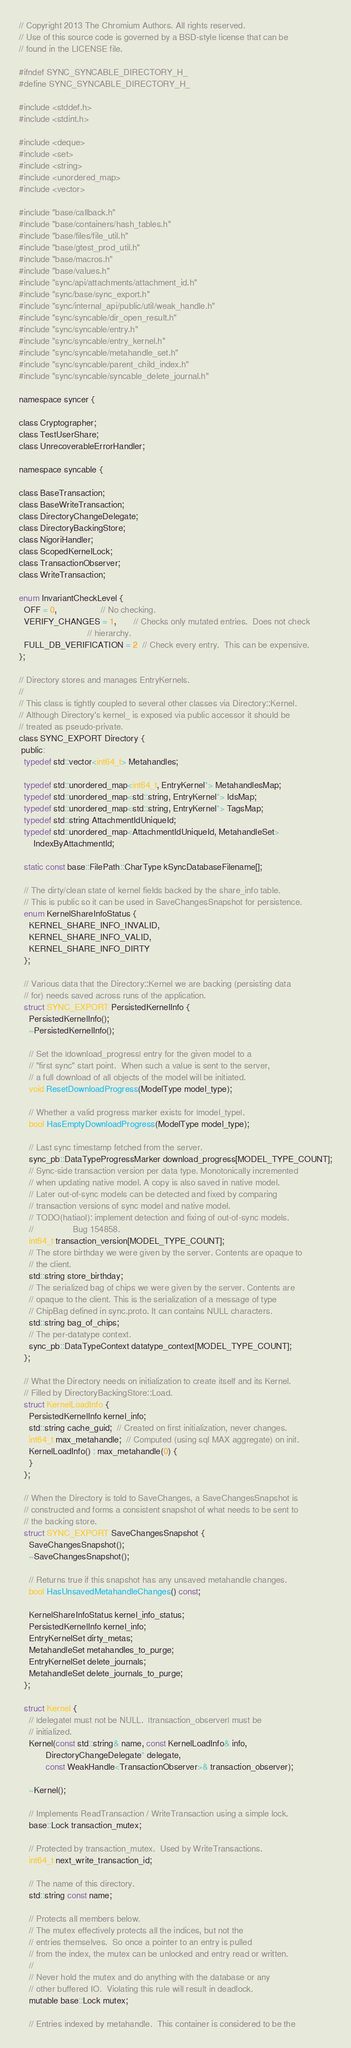<code> <loc_0><loc_0><loc_500><loc_500><_C_>// Copyright 2013 The Chromium Authors. All rights reserved.
// Use of this source code is governed by a BSD-style license that can be
// found in the LICENSE file.

#ifndef SYNC_SYNCABLE_DIRECTORY_H_
#define SYNC_SYNCABLE_DIRECTORY_H_

#include <stddef.h>
#include <stdint.h>

#include <deque>
#include <set>
#include <string>
#include <unordered_map>
#include <vector>

#include "base/callback.h"
#include "base/containers/hash_tables.h"
#include "base/files/file_util.h"
#include "base/gtest_prod_util.h"
#include "base/macros.h"
#include "base/values.h"
#include "sync/api/attachments/attachment_id.h"
#include "sync/base/sync_export.h"
#include "sync/internal_api/public/util/weak_handle.h"
#include "sync/syncable/dir_open_result.h"
#include "sync/syncable/entry.h"
#include "sync/syncable/entry_kernel.h"
#include "sync/syncable/metahandle_set.h"
#include "sync/syncable/parent_child_index.h"
#include "sync/syncable/syncable_delete_journal.h"

namespace syncer {

class Cryptographer;
class TestUserShare;
class UnrecoverableErrorHandler;

namespace syncable {

class BaseTransaction;
class BaseWriteTransaction;
class DirectoryChangeDelegate;
class DirectoryBackingStore;
class NigoriHandler;
class ScopedKernelLock;
class TransactionObserver;
class WriteTransaction;

enum InvariantCheckLevel {
  OFF = 0,                  // No checking.
  VERIFY_CHANGES = 1,       // Checks only mutated entries.  Does not check
                            // hierarchy.
  FULL_DB_VERIFICATION = 2  // Check every entry.  This can be expensive.
};

// Directory stores and manages EntryKernels.
//
// This class is tightly coupled to several other classes via Directory::Kernel.
// Although Directory's kernel_ is exposed via public accessor it should be
// treated as pseudo-private.
class SYNC_EXPORT Directory {
 public:
  typedef std::vector<int64_t> Metahandles;

  typedef std::unordered_map<int64_t, EntryKernel*> MetahandlesMap;
  typedef std::unordered_map<std::string, EntryKernel*> IdsMap;
  typedef std::unordered_map<std::string, EntryKernel*> TagsMap;
  typedef std::string AttachmentIdUniqueId;
  typedef std::unordered_map<AttachmentIdUniqueId, MetahandleSet>
      IndexByAttachmentId;

  static const base::FilePath::CharType kSyncDatabaseFilename[];

  // The dirty/clean state of kernel fields backed by the share_info table.
  // This is public so it can be used in SaveChangesSnapshot for persistence.
  enum KernelShareInfoStatus {
    KERNEL_SHARE_INFO_INVALID,
    KERNEL_SHARE_INFO_VALID,
    KERNEL_SHARE_INFO_DIRTY
  };

  // Various data that the Directory::Kernel we are backing (persisting data
  // for) needs saved across runs of the application.
  struct SYNC_EXPORT PersistedKernelInfo {
    PersistedKernelInfo();
    ~PersistedKernelInfo();

    // Set the |download_progress| entry for the given model to a
    // "first sync" start point.  When such a value is sent to the server,
    // a full download of all objects of the model will be initiated.
    void ResetDownloadProgress(ModelType model_type);

    // Whether a valid progress marker exists for |model_type|.
    bool HasEmptyDownloadProgress(ModelType model_type);

    // Last sync timestamp fetched from the server.
    sync_pb::DataTypeProgressMarker download_progress[MODEL_TYPE_COUNT];
    // Sync-side transaction version per data type. Monotonically incremented
    // when updating native model. A copy is also saved in native model.
    // Later out-of-sync models can be detected and fixed by comparing
    // transaction versions of sync model and native model.
    // TODO(hatiaol): implement detection and fixing of out-of-sync models.
    //                Bug 154858.
    int64_t transaction_version[MODEL_TYPE_COUNT];
    // The store birthday we were given by the server. Contents are opaque to
    // the client.
    std::string store_birthday;
    // The serialized bag of chips we were given by the server. Contents are
    // opaque to the client. This is the serialization of a message of type
    // ChipBag defined in sync.proto. It can contains NULL characters.
    std::string bag_of_chips;
    // The per-datatype context.
    sync_pb::DataTypeContext datatype_context[MODEL_TYPE_COUNT];
  };

  // What the Directory needs on initialization to create itself and its Kernel.
  // Filled by DirectoryBackingStore::Load.
  struct KernelLoadInfo {
    PersistedKernelInfo kernel_info;
    std::string cache_guid;  // Created on first initialization, never changes.
    int64_t max_metahandle;  // Computed (using sql MAX aggregate) on init.
    KernelLoadInfo() : max_metahandle(0) {
    }
  };

  // When the Directory is told to SaveChanges, a SaveChangesSnapshot is
  // constructed and forms a consistent snapshot of what needs to be sent to
  // the backing store.
  struct SYNC_EXPORT SaveChangesSnapshot {
    SaveChangesSnapshot();
    ~SaveChangesSnapshot();

    // Returns true if this snapshot has any unsaved metahandle changes.
    bool HasUnsavedMetahandleChanges() const;

    KernelShareInfoStatus kernel_info_status;
    PersistedKernelInfo kernel_info;
    EntryKernelSet dirty_metas;
    MetahandleSet metahandles_to_purge;
    EntryKernelSet delete_journals;
    MetahandleSet delete_journals_to_purge;
  };

  struct Kernel {
    // |delegate| must not be NULL.  |transaction_observer| must be
    // initialized.
    Kernel(const std::string& name, const KernelLoadInfo& info,
           DirectoryChangeDelegate* delegate,
           const WeakHandle<TransactionObserver>& transaction_observer);

    ~Kernel();

    // Implements ReadTransaction / WriteTransaction using a simple lock.
    base::Lock transaction_mutex;

    // Protected by transaction_mutex.  Used by WriteTransactions.
    int64_t next_write_transaction_id;

    // The name of this directory.
    std::string const name;

    // Protects all members below.
    // The mutex effectively protects all the indices, but not the
    // entries themselves.  So once a pointer to an entry is pulled
    // from the index, the mutex can be unlocked and entry read or written.
    //
    // Never hold the mutex and do anything with the database or any
    // other buffered IO.  Violating this rule will result in deadlock.
    mutable base::Lock mutex;

    // Entries indexed by metahandle.  This container is considered to be the</code> 